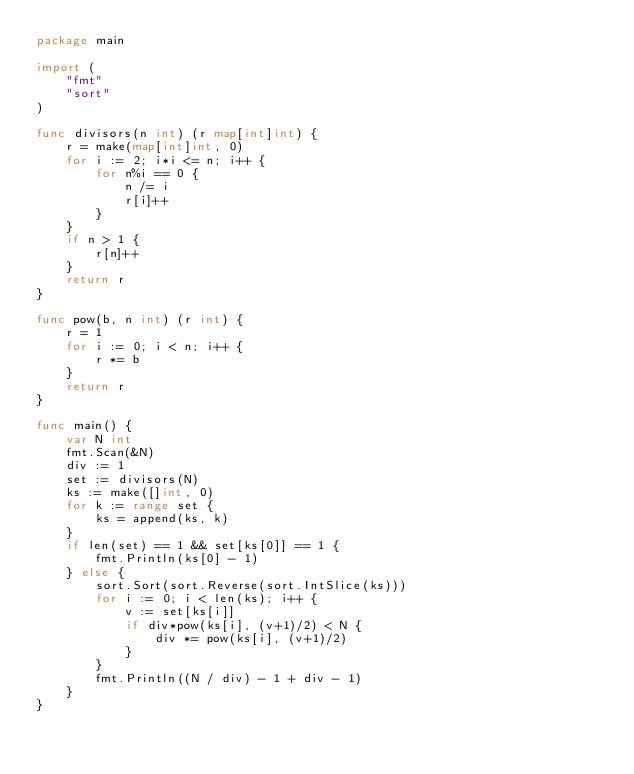Convert code to text. <code><loc_0><loc_0><loc_500><loc_500><_Go_>package main

import (
	"fmt"
	"sort"
)

func divisors(n int) (r map[int]int) {
	r = make(map[int]int, 0)
	for i := 2; i*i <= n; i++ {
		for n%i == 0 {
			n /= i
			r[i]++
		}
	}
	if n > 1 {
		r[n]++
	}
	return r
}

func pow(b, n int) (r int) {
	r = 1
	for i := 0; i < n; i++ {
		r *= b
	}
	return r
}

func main() {
	var N int
	fmt.Scan(&N)
	div := 1
	set := divisors(N)
	ks := make([]int, 0)
	for k := range set {
		ks = append(ks, k)
	}
	if len(set) == 1 && set[ks[0]] == 1 {
		fmt.Println(ks[0] - 1)
	} else {
		sort.Sort(sort.Reverse(sort.IntSlice(ks)))
		for i := 0; i < len(ks); i++ {
			v := set[ks[i]]
			if div*pow(ks[i], (v+1)/2) < N {
				div *= pow(ks[i], (v+1)/2)
			}
		}
		fmt.Println((N / div) - 1 + div - 1)
	}
}
</code> 